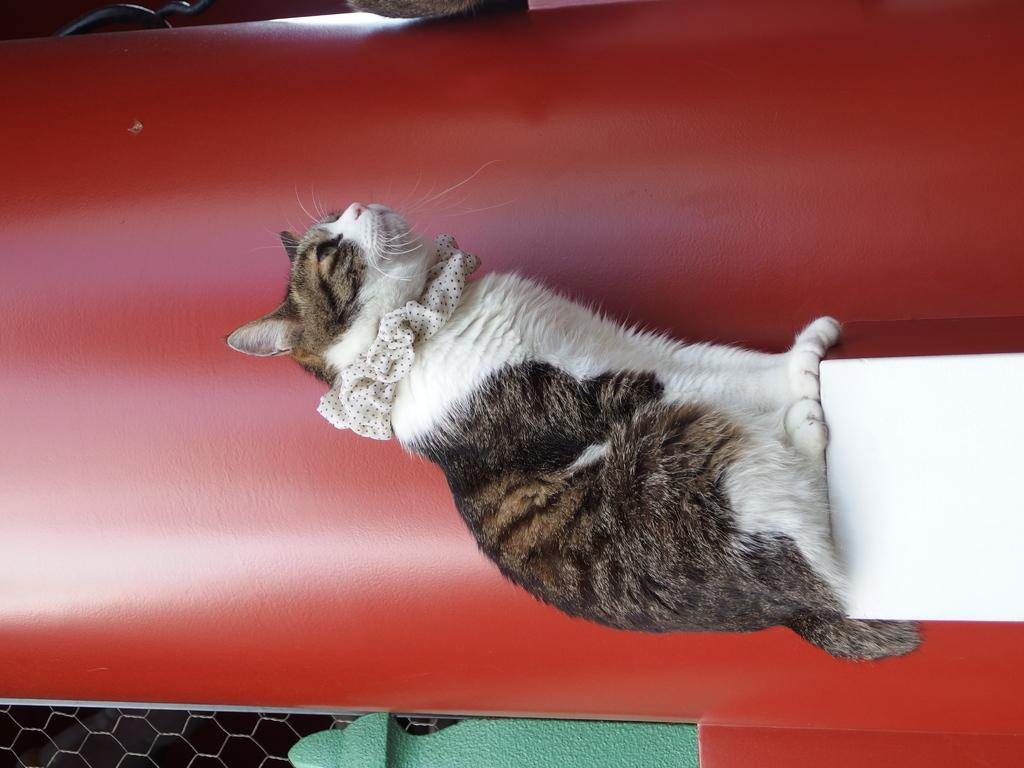What animal is present in the image? There is a cat on a stand in the image. What is the color of the pillar in the image? There is a red pillar in the image. What type of material is visible in the image? There is mesh in the image. What type of polish is the cat using in the image? There is no indication in the image that the cat is using any polish. How many airplanes can be seen in the image? There are no airplanes present in the image. 